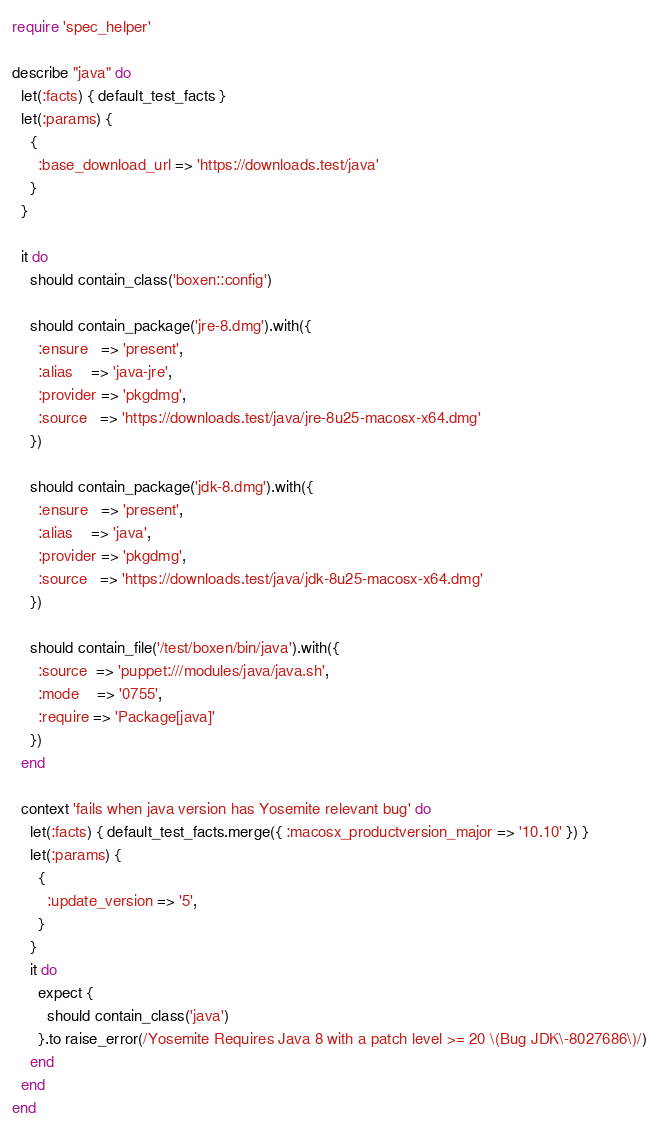<code> <loc_0><loc_0><loc_500><loc_500><_Ruby_>require 'spec_helper'

describe "java" do
  let(:facts) { default_test_facts }
  let(:params) {
    {
      :base_download_url => 'https://downloads.test/java'
    }
  }

  it do
    should contain_class('boxen::config')

    should contain_package('jre-8.dmg').with({
      :ensure   => 'present',
      :alias    => 'java-jre',
      :provider => 'pkgdmg',
      :source   => 'https://downloads.test/java/jre-8u25-macosx-x64.dmg'
    })

    should contain_package('jdk-8.dmg').with({
      :ensure   => 'present',
      :alias    => 'java',
      :provider => 'pkgdmg',
      :source   => 'https://downloads.test/java/jdk-8u25-macosx-x64.dmg'
    })

    should contain_file('/test/boxen/bin/java').with({
      :source  => 'puppet:///modules/java/java.sh',
      :mode    => '0755',
      :require => 'Package[java]'
    })
  end

  context 'fails when java version has Yosemite relevant bug' do
    let(:facts) { default_test_facts.merge({ :macosx_productversion_major => '10.10' }) }
    let(:params) {
      {
        :update_version => '5',
      }
    }
    it do
      expect {
        should contain_class('java')
      }.to raise_error(/Yosemite Requires Java 8 with a patch level >= 20 \(Bug JDK\-8027686\)/)
    end
  end
end
</code> 